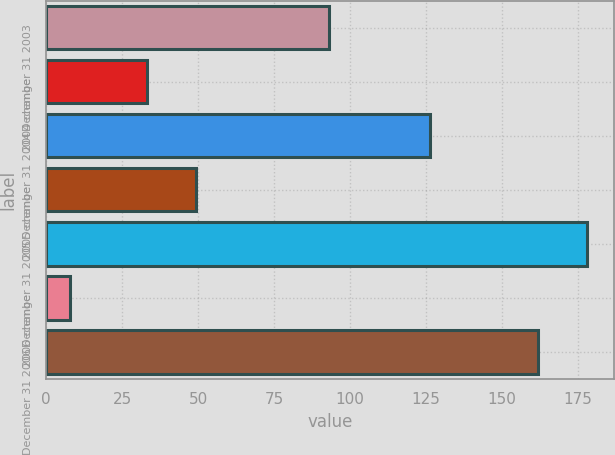Convert chart. <chart><loc_0><loc_0><loc_500><loc_500><bar_chart><fcel>December 31 2003<fcel>2004 change<fcel>December 31 2004<fcel>2005 change<fcel>December 31 2005<fcel>2006 change<fcel>December 31 2006<nl><fcel>93.1<fcel>33.2<fcel>126.3<fcel>49.39<fcel>178.09<fcel>8<fcel>161.9<nl></chart> 